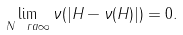<formula> <loc_0><loc_0><loc_500><loc_500>\lim _ { N \ r a \infty } \nu ( | H - \nu ( H ) | ) = 0 .</formula> 